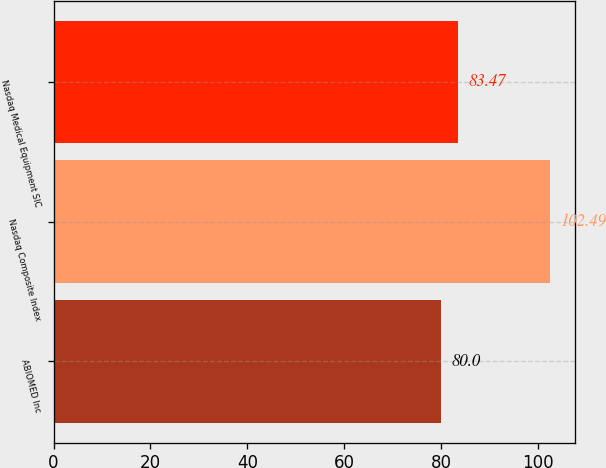Convert chart to OTSL. <chart><loc_0><loc_0><loc_500><loc_500><bar_chart><fcel>ABIOMED Inc<fcel>Nasdaq Composite Index<fcel>Nasdaq Medical Equipment SIC<nl><fcel>80<fcel>102.49<fcel>83.47<nl></chart> 